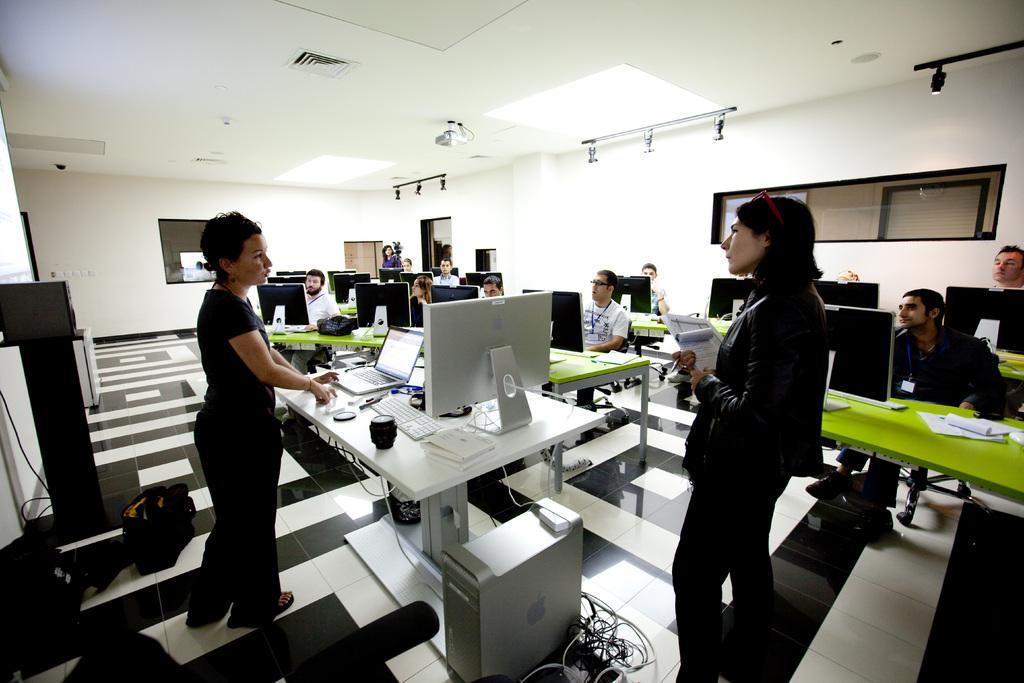Please provide a concise description of this image. In this picture we can see two persons are standing on the floor. And some persons are sitting on the chairs. These are the tables. On the table there is a laptop, monitor, and keyboard. And on the background there is a wall. And these are the lights. 